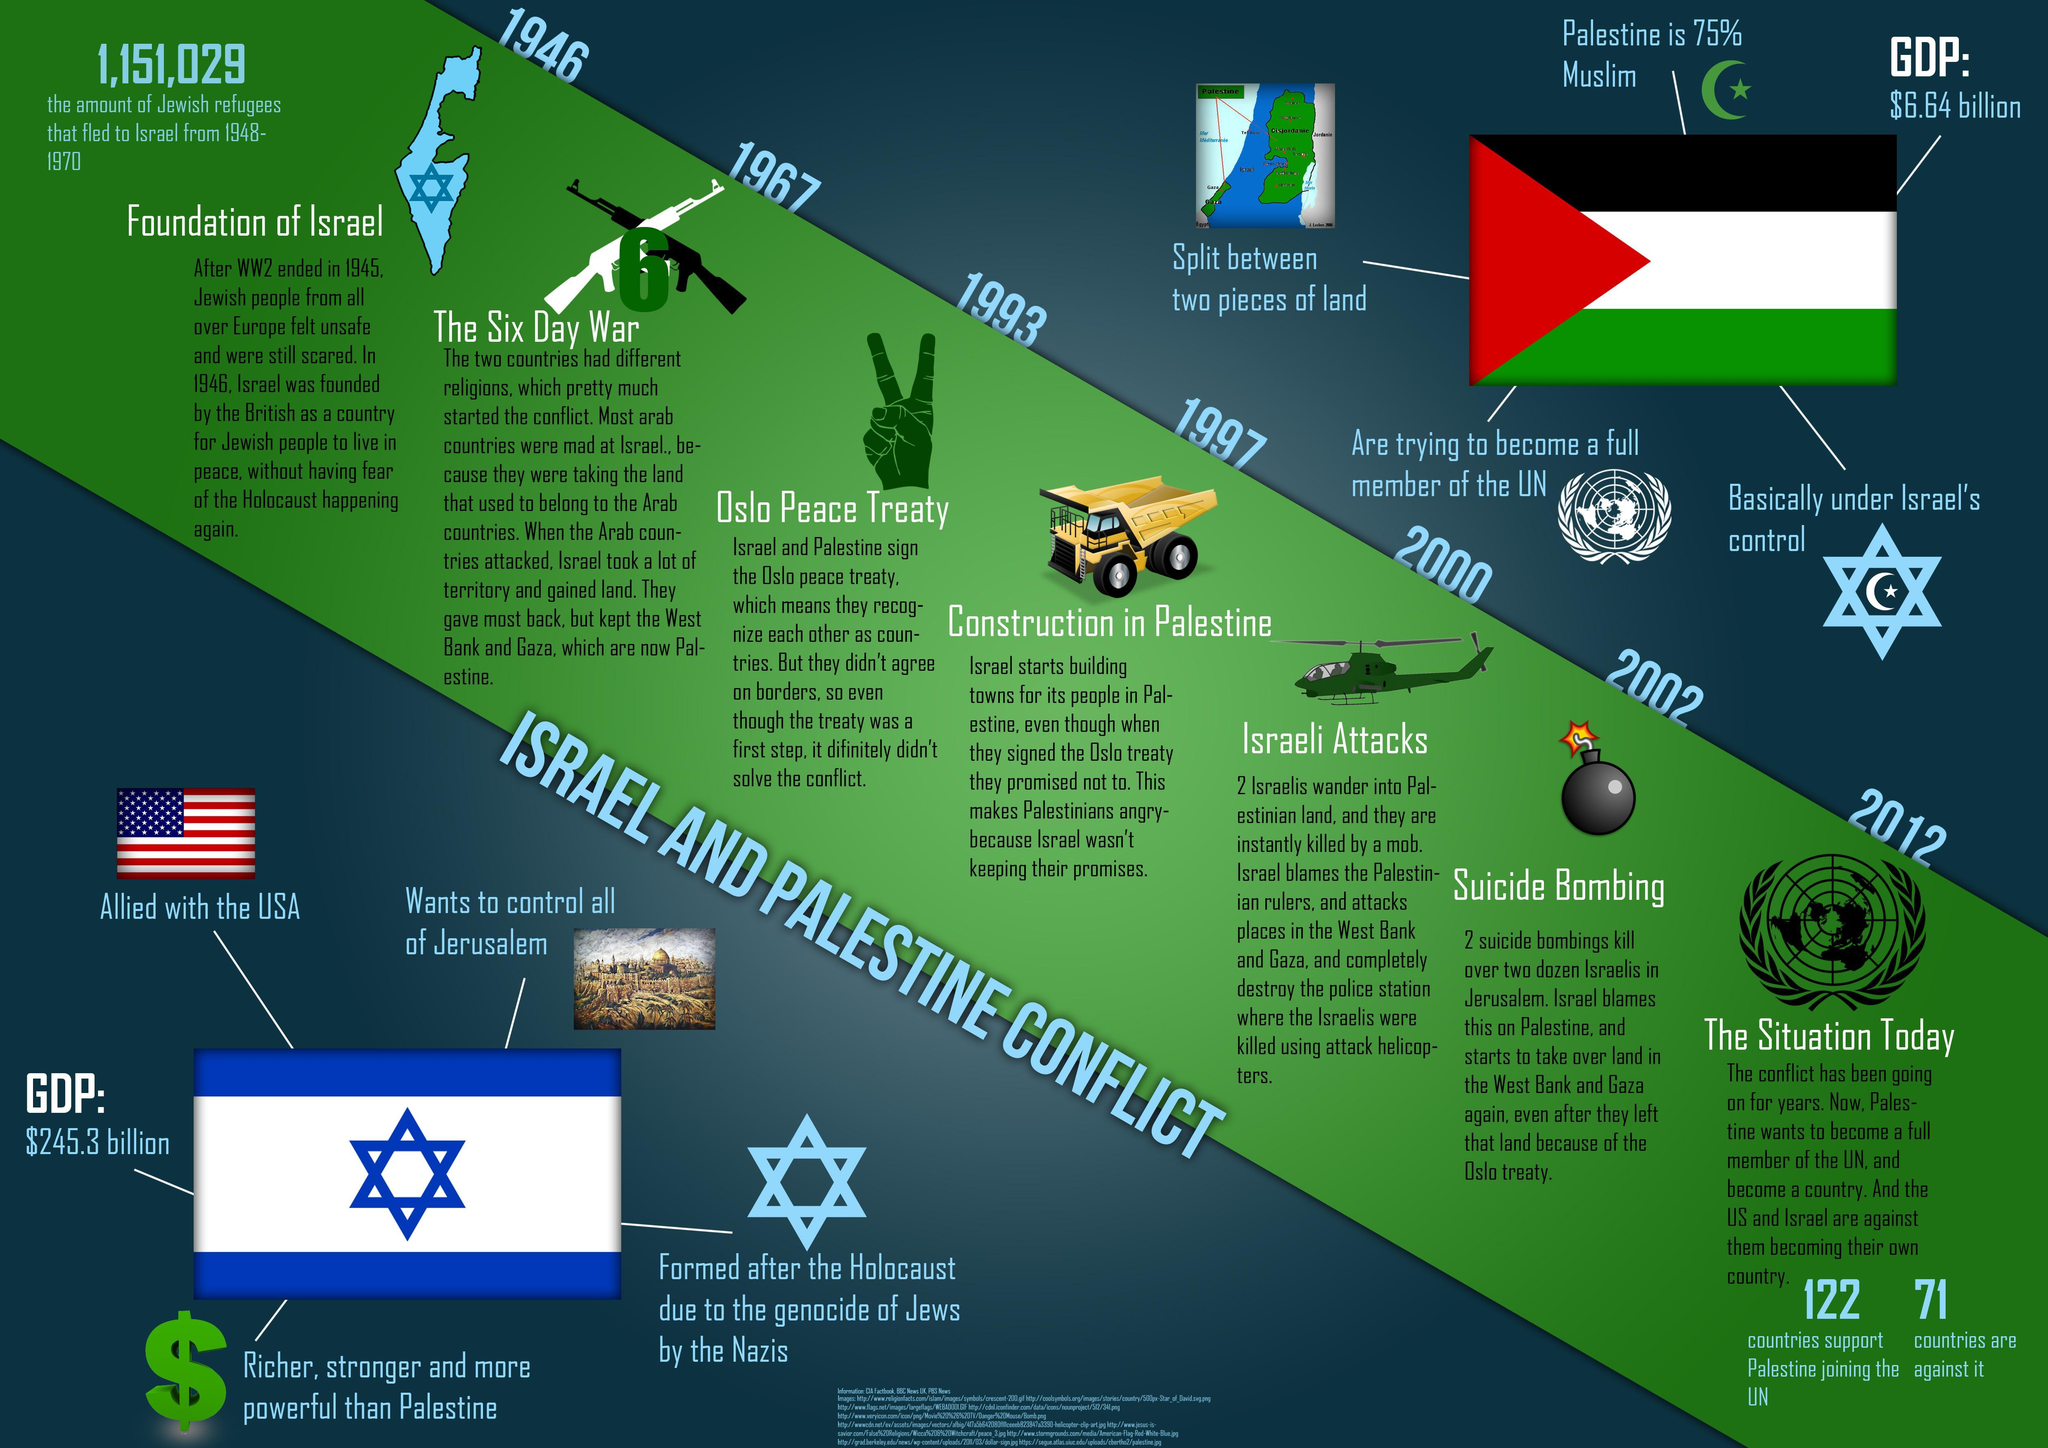How many nations do not support Palestine for joining the UN?
Answer the question with a short phrase. 71 In which year the famous "Suicide Bombing" happened? 2002 How many nations support Palestine for joining the UN? 122 When did the Oslo Peace Treaty was signed? 1993 